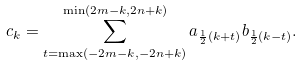<formula> <loc_0><loc_0><loc_500><loc_500>c _ { k } = \sum _ { t = \max ( - 2 m - k , - 2 n + k ) } ^ { \min ( 2 m - k , 2 n + k ) } a _ { \frac { 1 } { 2 } ( k + t ) } b _ { \frac { 1 } { 2 } ( k - t ) } .</formula> 